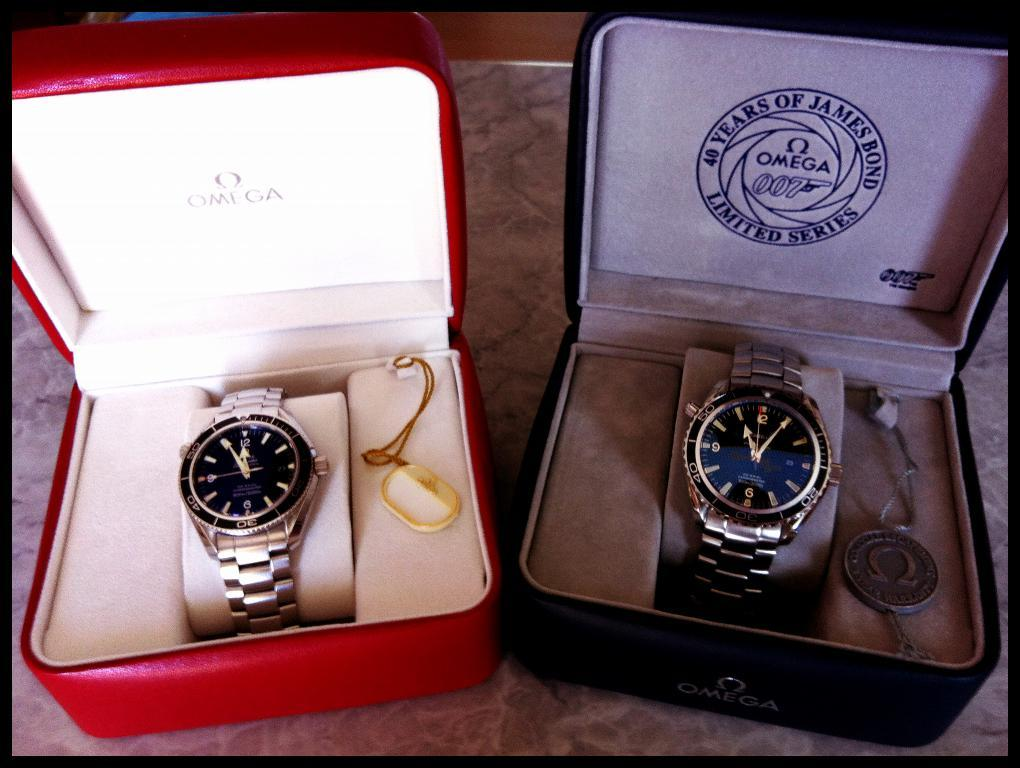What objects are present in the image that are related to timekeeping? There are two watches in the image. How are the watches being stored or displayed in the image? The watches are in different boxes in the image. What else can be seen on the surface in the image? There are tags on the surface in the image. What type of coat is hanging on the wall in the image? There is no coat present in the image. What can be seen being poured into a can in the image? There is no can or pouring action present in the image. What is the source of laughter in the image? There is no laughter or any indication of humor in the image. 